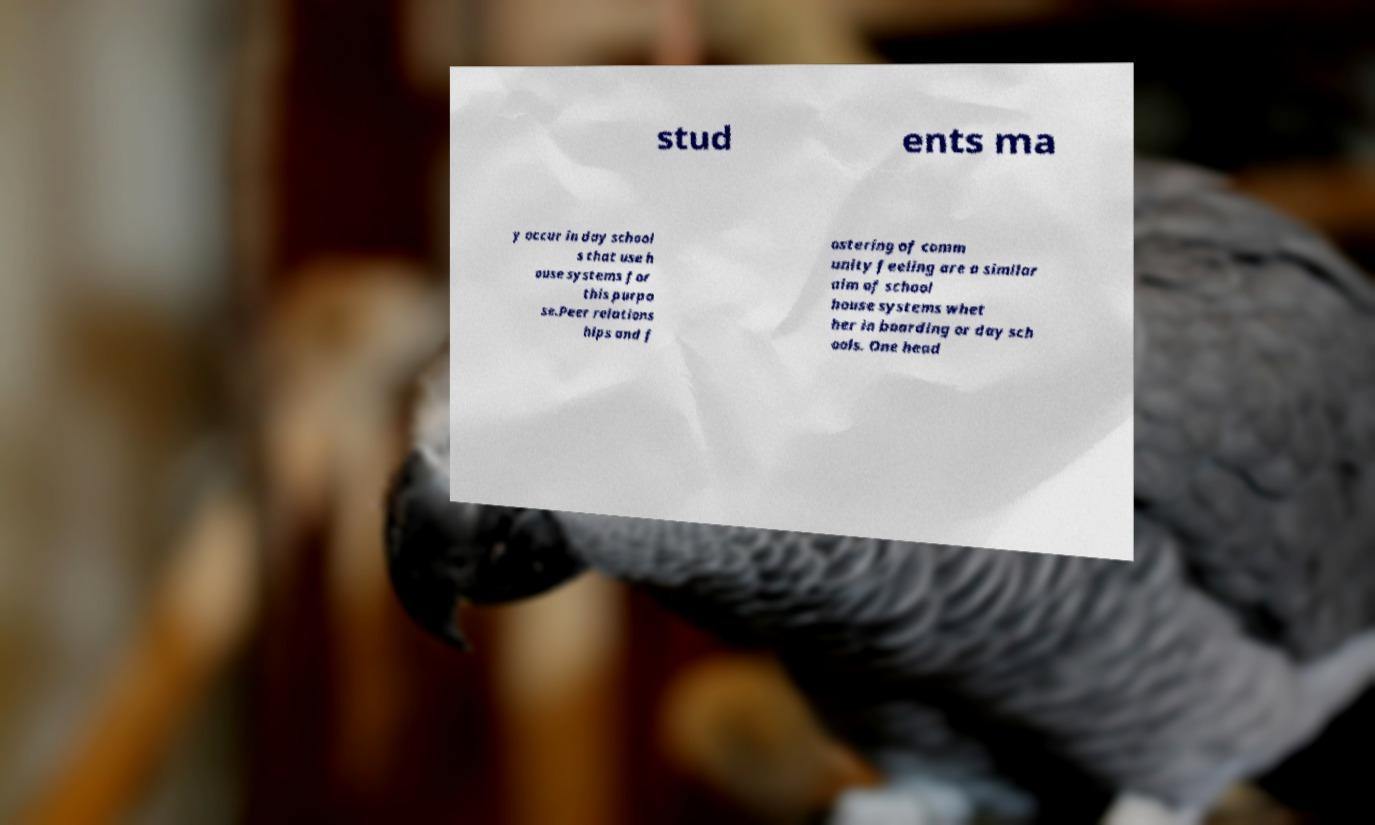Can you read and provide the text displayed in the image?This photo seems to have some interesting text. Can you extract and type it out for me? stud ents ma y occur in day school s that use h ouse systems for this purpo se.Peer relations hips and f ostering of comm unity feeling are a similar aim of school house systems whet her in boarding or day sch ools. One head 